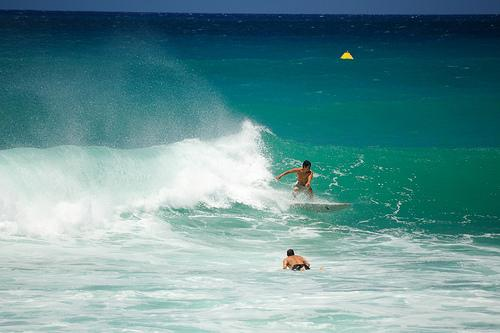Based on the captions given, determine if the person in the image is wearing a shirt or not. The person in the image is not wearing a shirt. What is the total number of unique objects mentioned in the captions and their general context? 5 unique objects - white wave in water, people in the ocean, person on a surfboard, ocean wave, and mac laptop on a desk. What is the major sentiment and feeling that can be perceived from the people in the image? The major sentiment is joy and excitement as people are enjoying their day and getting good exercise. In the image, are there any non-sports related objects and if so, what are they placed on? Yes, there are non-sports related objects like 'mac laptop' which are placed on top of a desk. Can you identify an object in the image that is present multiple times with different captions mentioning different perspectives of the same item? Yes, the surfboard is mentioned as both 'white surfboard' and 'surfboard is white' with different bounding box coordinates. Describe the interaction between the subjects and their environment in the image. Surfers are riding ocean waves and getting wet while being out in the sunshine and close to a beach, enjoying their day and getting good exercise. What is the most common activity being performed by people in the image? Surfing on ocean waves. An orange lifeguard tower stands tall at the edge of the beach. No, it's not mentioned in the image. 